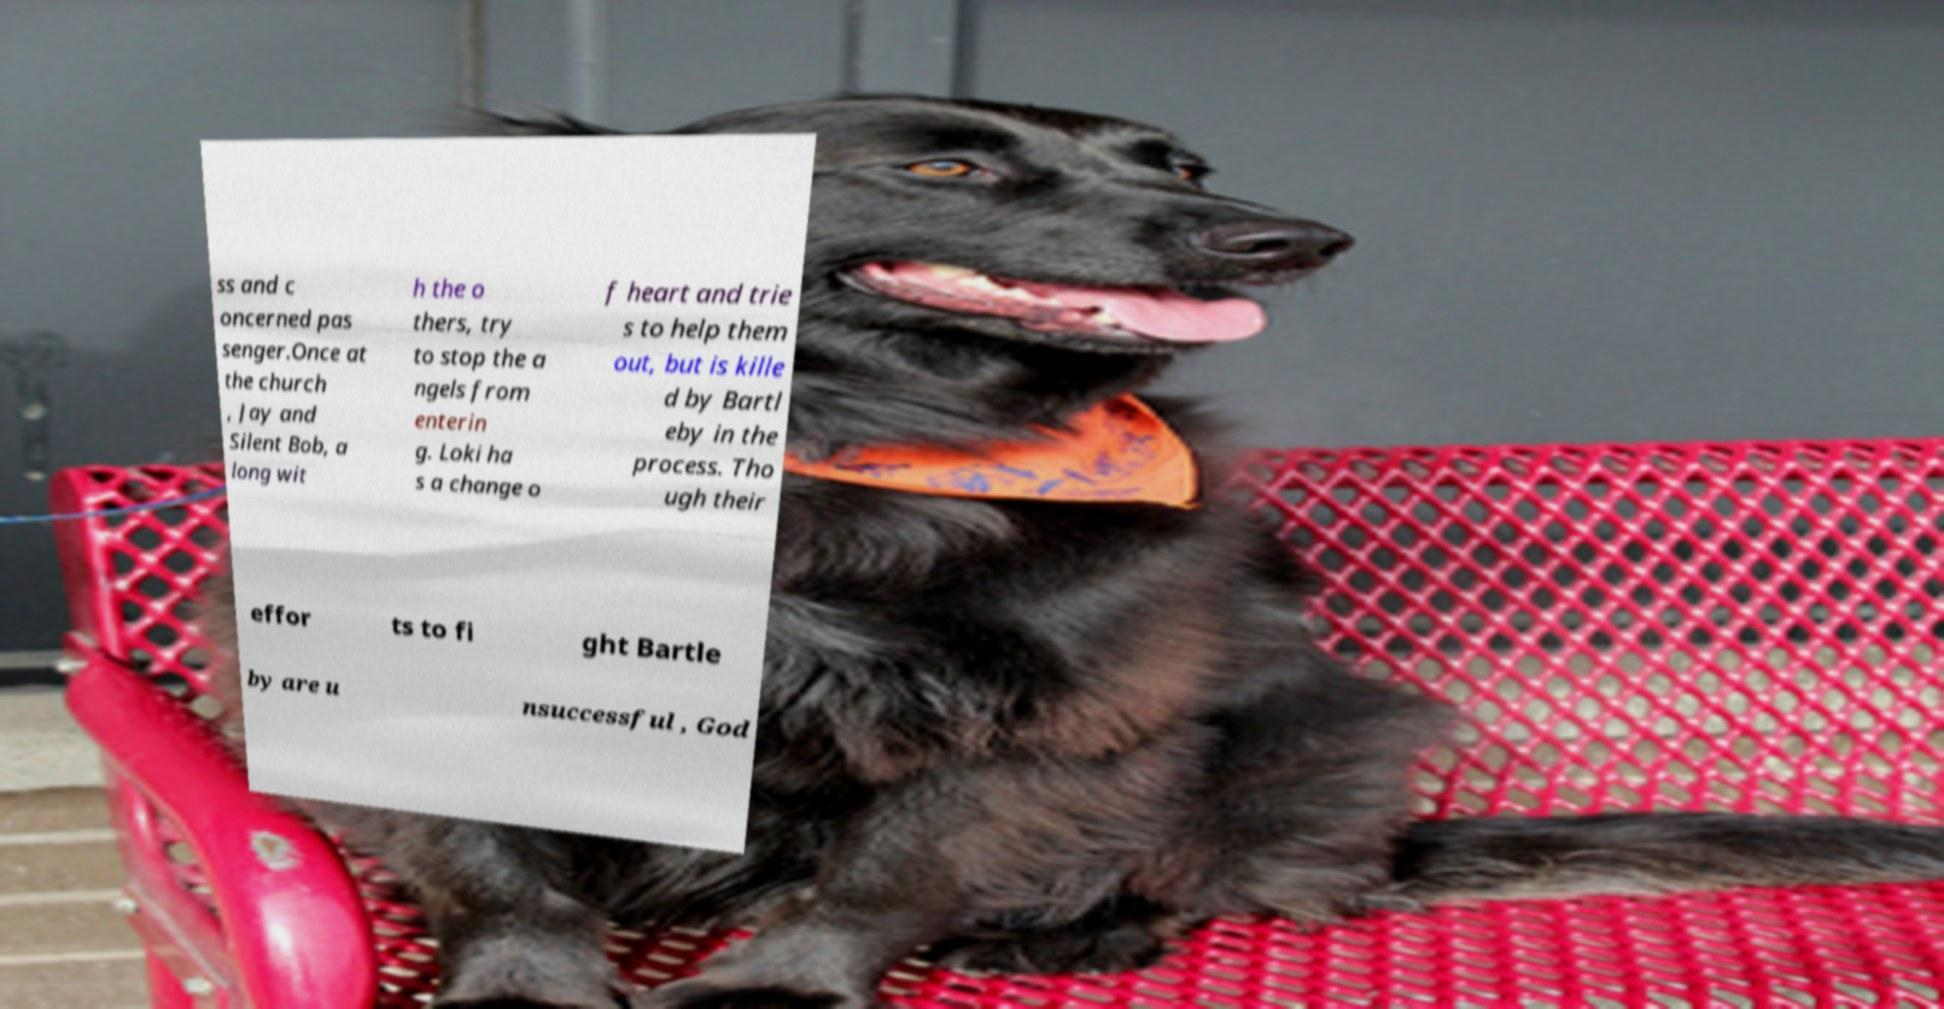There's text embedded in this image that I need extracted. Can you transcribe it verbatim? ss and c oncerned pas senger.Once at the church , Jay and Silent Bob, a long wit h the o thers, try to stop the a ngels from enterin g. Loki ha s a change o f heart and trie s to help them out, but is kille d by Bartl eby in the process. Tho ugh their effor ts to fi ght Bartle by are u nsuccessful , God 